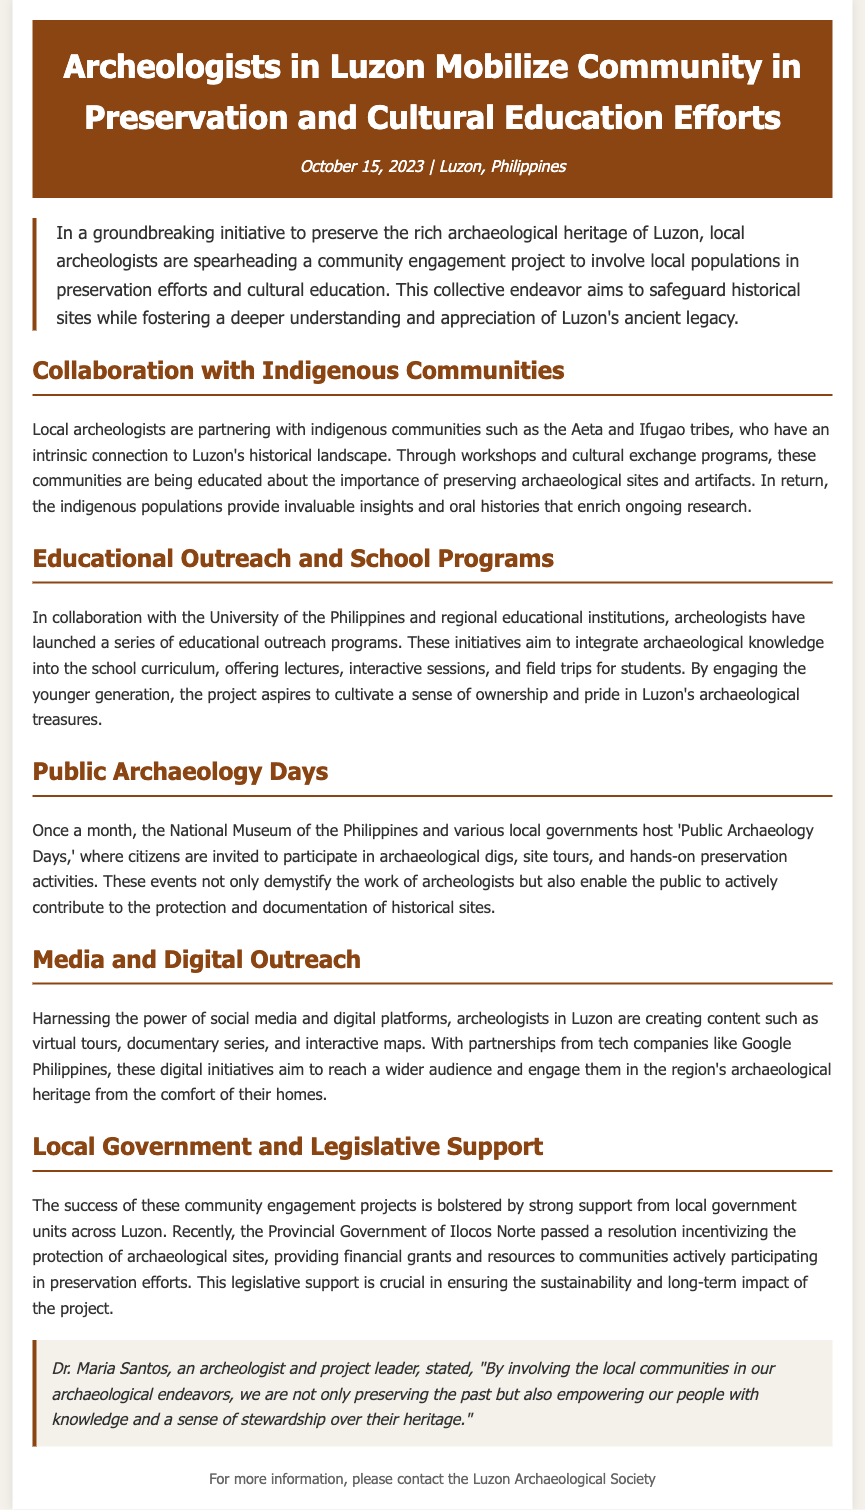What is the date of the press release? The date of the press release is stated in the document as October 15, 2023.
Answer: October 15, 2023 Who is involved in the community engagement project? The document mentions local archeologists and indigenous communities such as the Aeta and Ifugao tribes as involved in the project.
Answer: Aeta and Ifugao tribes What type of educational programs are being launched? The press release describes educational outreach programs that integrate archaeological knowledge into school curriculums.
Answer: Educational outreach programs How often do 'Public Archaeology Days' occur? The document notes that 'Public Archaeology Days' are held once a month.
Answer: Once a month What is the role of the Provincial Government of Ilocos Norte in the project? The document specifies that the Provincial Government of Ilocos Norte passed a resolution providing financial grants and resources for preservation efforts.
Answer: Providing financial grants and resources What does Dr. Maria Santos emphasize about community involvement? The quote highlights that empowering local communities is vital to preservation efforts, giving them knowledge and stewardship over their heritage.
Answer: Empowering our people with knowledge and a sense of stewardship What partnership does the project have for digital outreach? The document states that tech companies, specifically Google Philippines, are partnering with archeologists for digital initiatives.
Answer: Google Philippines What is the main goal of the community engagement project? The main goal outlined in the press release is to preserve archaeological heritage while fostering appreciation and understanding of it within local communities.
Answer: Preserve archaeological heritage 